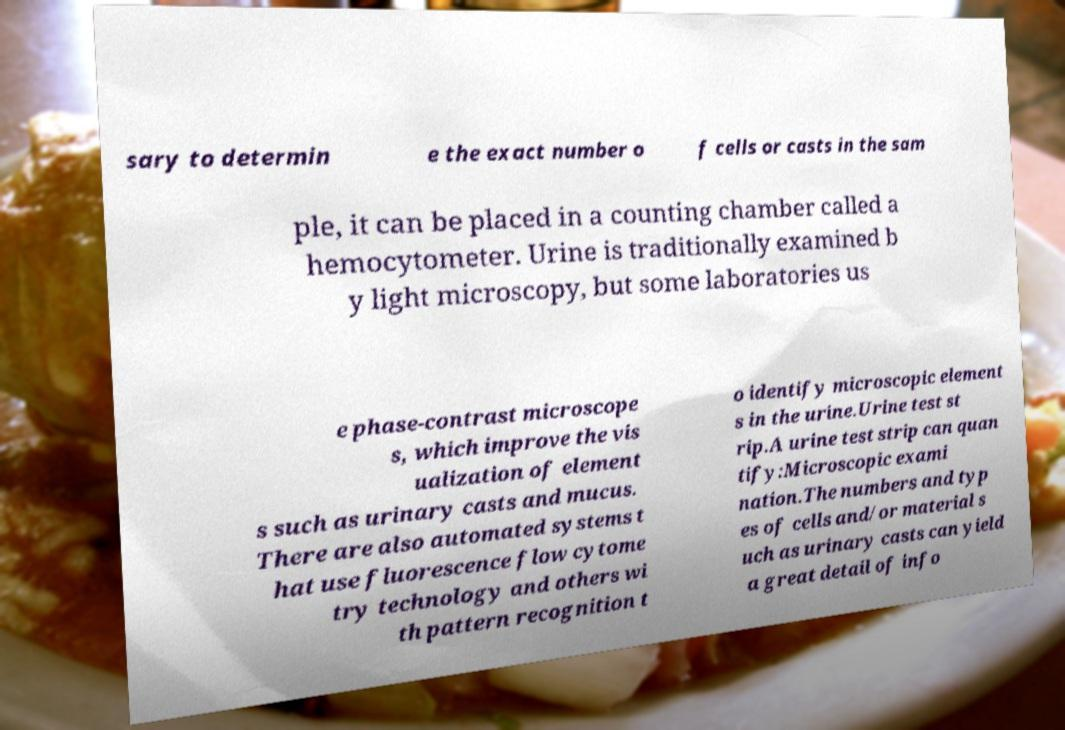Please identify and transcribe the text found in this image. sary to determin e the exact number o f cells or casts in the sam ple, it can be placed in a counting chamber called a hemocytometer. Urine is traditionally examined b y light microscopy, but some laboratories us e phase-contrast microscope s, which improve the vis ualization of element s such as urinary casts and mucus. There are also automated systems t hat use fluorescence flow cytome try technology and others wi th pattern recognition t o identify microscopic element s in the urine.Urine test st rip.A urine test strip can quan tify:Microscopic exami nation.The numbers and typ es of cells and/or material s uch as urinary casts can yield a great detail of info 